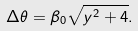Convert formula to latex. <formula><loc_0><loc_0><loc_500><loc_500>\Delta \theta = \beta _ { 0 } \sqrt { y ^ { 2 } + 4 } .</formula> 